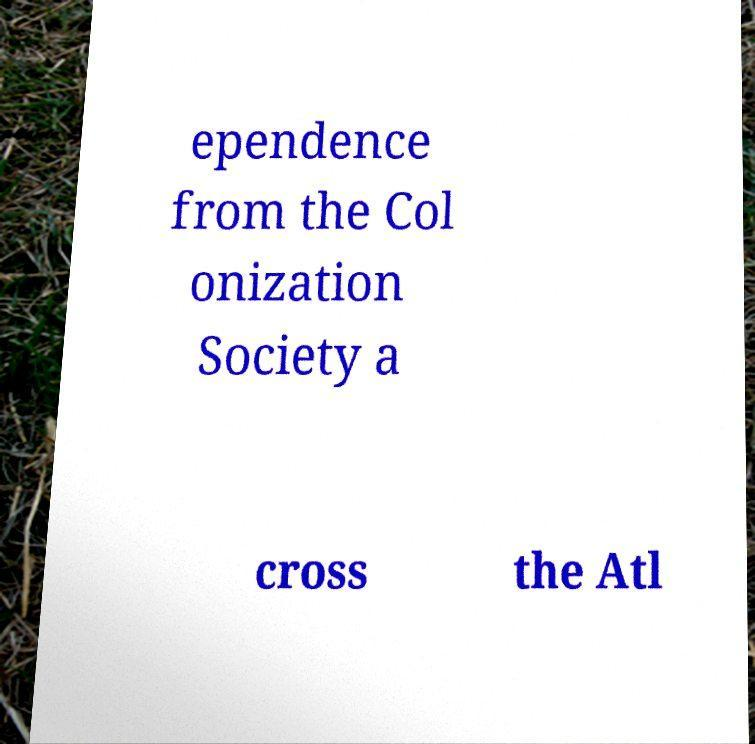Please identify and transcribe the text found in this image. ependence from the Col onization Society a cross the Atl 